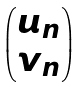<formula> <loc_0><loc_0><loc_500><loc_500>\begin{pmatrix} u _ { n } \\ v _ { n } \end{pmatrix}</formula> 